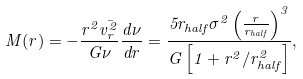Convert formula to latex. <formula><loc_0><loc_0><loc_500><loc_500>M ( r ) = - \frac { r ^ { 2 } \bar { v _ { r } ^ { 2 } } } { G \nu } \frac { d \nu } { d r } = \frac { 5 r _ { h a l f } \sigma ^ { 2 } \left ( \frac { r } { r _ { h a l f } } \right ) ^ { 3 } } { G \left [ 1 + r ^ { 2 } / r _ { h a l f } ^ { 2 } \right ] } ,</formula> 